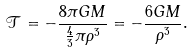<formula> <loc_0><loc_0><loc_500><loc_500>\mathcal { T } = - \frac { 8 \pi G M } { \frac { 4 } { 3 } \pi \rho ^ { 3 } } = - \frac { 6 G M } { \rho ^ { 3 } } .</formula> 